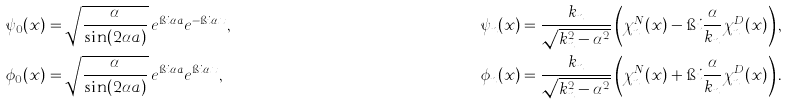Convert formula to latex. <formula><loc_0><loc_0><loc_500><loc_500>\psi _ { 0 } ( x ) & = \sqrt { \frac { \alpha } { \sin ( 2 \alpha a ) } } \, e ^ { \i i \alpha a } e ^ { - \i i \alpha x } , & \psi _ { n } ( x ) & = \frac { k _ { n } } { \sqrt { k _ { n } ^ { 2 } - \alpha ^ { 2 } } } \left ( \chi _ { n } ^ { N } ( x ) - \i i \frac { \alpha } { k _ { n } } \chi _ { n } ^ { D } ( x ) \right ) , \\ \phi _ { 0 } ( x ) & = \sqrt { \frac { \alpha } { \sin ( 2 \alpha a ) } } \, e ^ { \i i \alpha a } e ^ { \i i \alpha x } , & \phi _ { n } ( x ) & = \frac { k _ { n } } { \sqrt { k _ { n } ^ { 2 } - \alpha ^ { 2 } } } \left ( \chi _ { n } ^ { N } ( x ) + \i i \frac { \alpha } { k _ { n } } \chi _ { n } ^ { D } ( x ) \right ) .</formula> 